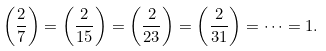<formula> <loc_0><loc_0><loc_500><loc_500>\left ( { \frac { 2 } { 7 } } \right ) = \left ( { \frac { 2 } { 1 5 } } \right ) = \left ( { \frac { 2 } { 2 3 } } \right ) = \left ( { \frac { 2 } { 3 1 } } \right ) = \cdots = 1 .</formula> 